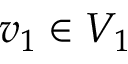<formula> <loc_0><loc_0><loc_500><loc_500>v _ { 1 } \in V _ { 1 }</formula> 